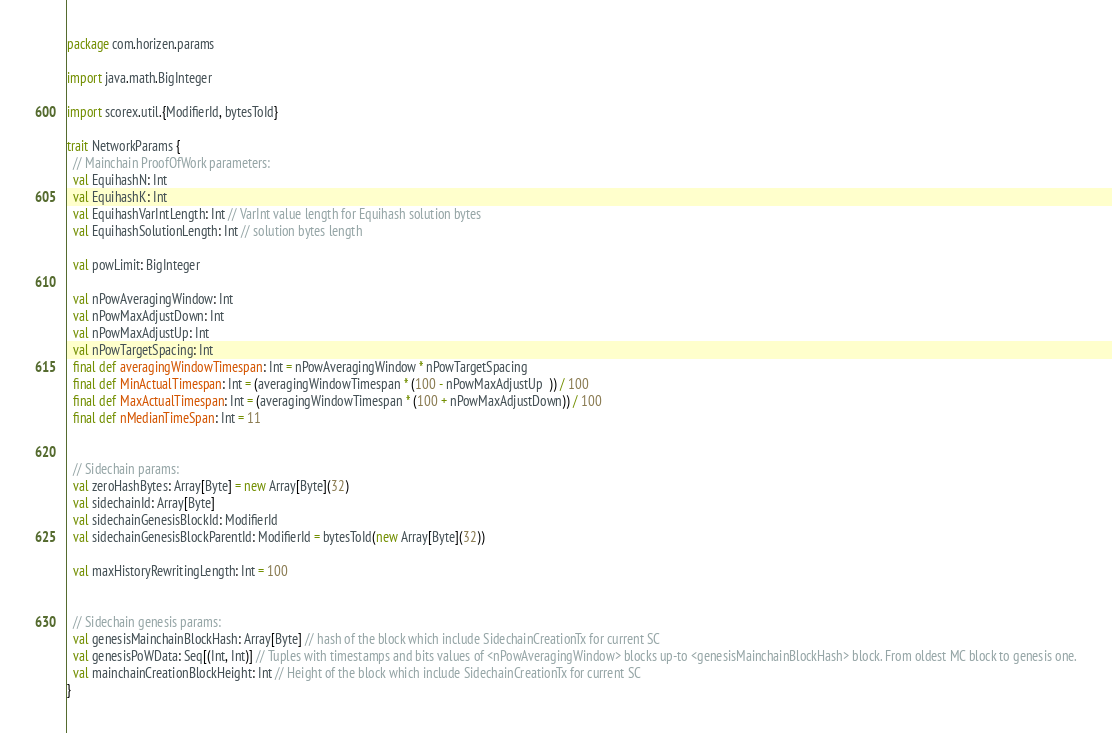<code> <loc_0><loc_0><loc_500><loc_500><_Scala_>package com.horizen.params

import java.math.BigInteger

import scorex.util.{ModifierId, bytesToId}

trait NetworkParams {
  // Mainchain ProofOfWork parameters:
  val EquihashN: Int
  val EquihashK: Int
  val EquihashVarIntLength: Int // VarInt value length for Equihash solution bytes
  val EquihashSolutionLength: Int // solution bytes length

  val powLimit: BigInteger

  val nPowAveragingWindow: Int
  val nPowMaxAdjustDown: Int
  val nPowMaxAdjustUp: Int
  val nPowTargetSpacing: Int
  final def averagingWindowTimespan: Int = nPowAveragingWindow * nPowTargetSpacing
  final def MinActualTimespan: Int = (averagingWindowTimespan * (100 - nPowMaxAdjustUp  )) / 100
  final def MaxActualTimespan: Int = (averagingWindowTimespan * (100 + nPowMaxAdjustDown)) / 100
  final def nMedianTimeSpan: Int = 11


  // Sidechain params:
  val zeroHashBytes: Array[Byte] = new Array[Byte](32)
  val sidechainId: Array[Byte]
  val sidechainGenesisBlockId: ModifierId
  val sidechainGenesisBlockParentId: ModifierId = bytesToId(new Array[Byte](32))

  val maxHistoryRewritingLength: Int = 100


  // Sidechain genesis params:
  val genesisMainchainBlockHash: Array[Byte] // hash of the block which include SidechainCreationTx for current SC
  val genesisPoWData: Seq[(Int, Int)] // Tuples with timestamps and bits values of <nPowAveragingWindow> blocks up-to <genesisMainchainBlockHash> block. From oldest MC block to genesis one.
  val mainchainCreationBlockHeight: Int // Height of the block which include SidechainCreationTx for current SC
}
</code> 